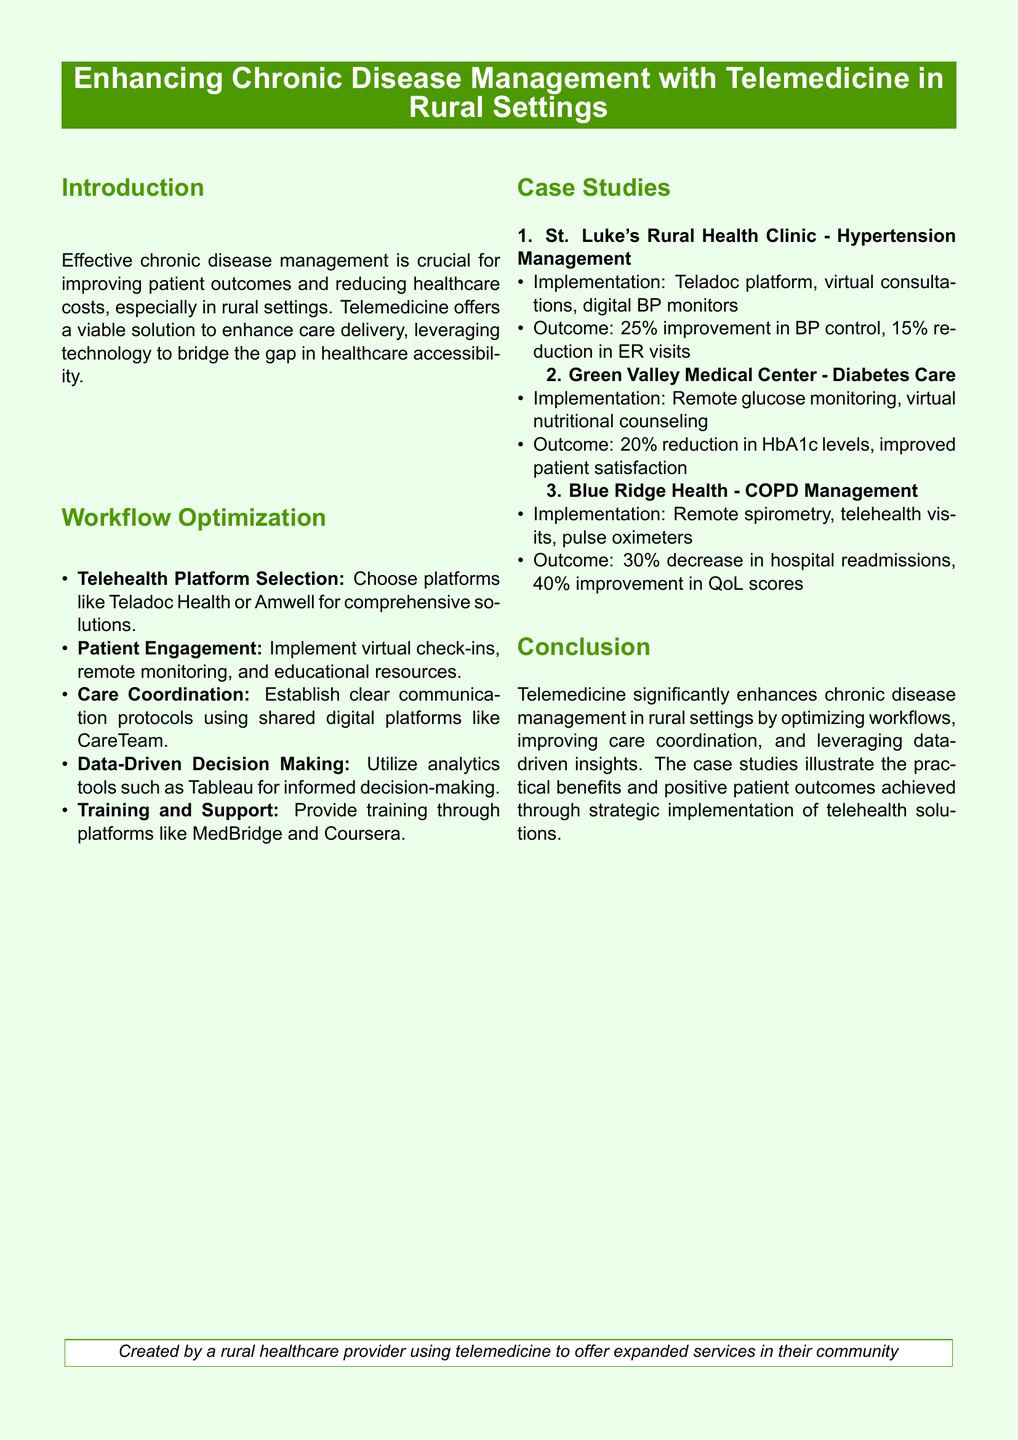what is the main focus of the whitepaper? The whitepaper discusses enhancing chronic disease management with telemedicine in rural settings.
Answer: enhancing chronic disease management with telemedicine in rural settings which telehealth platform is mentioned for hypertension management? The case study for hypertension management mentions the Teladoc platform.
Answer: Teladoc what percentage improvement in blood pressure control was achieved by St. Luke's Rural Health Clinic? St. Luke's achieved a 25% improvement in blood pressure control.
Answer: 25% what innovative approach did Green Valley Medical Center use for diabetes care? Green Valley Medical Center implemented remote glucose monitoring.
Answer: remote glucose monitoring how much did hospital readmissions decrease in Blue Ridge Health's COPD management? Blue Ridge Health experienced a 30% decrease in hospital readmissions.
Answer: 30% what is a recommended tool for data-driven decision making mentioned in the workflow optimization section? The document suggests using analytics tools such as Tableau for data-driven decision making.
Answer: Tableau what type of support is emphasized for healthcare provider training? The document emphasizes providing training through platforms like MedBridge and Coursera.
Answer: MedBridge and Coursera what was the outcome related to HbA1c levels for diabetes patients at Green Valley Medical Center? The case study indicated a 20% reduction in HbA1c levels.
Answer: 20% reduction in HbA1c levels what key benefit does telemedicine provide according to the conclusion? Telemedicine significantly enhances chronic disease management in rural settings.
Answer: enhances chronic disease management in rural settings 